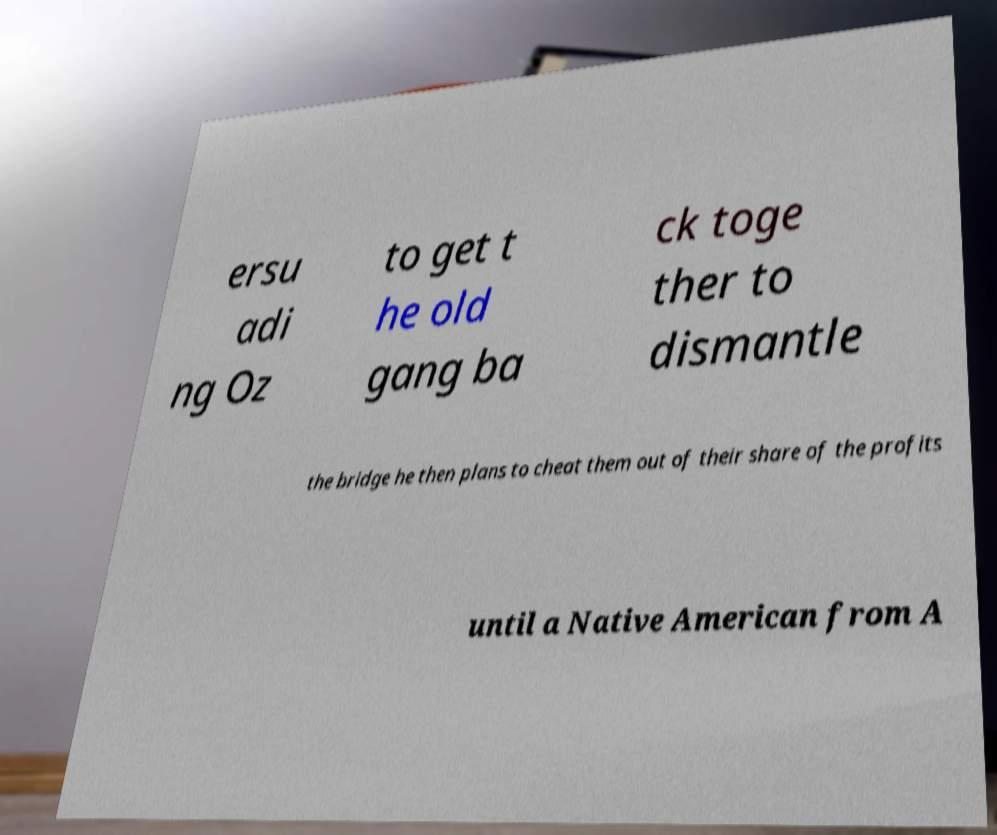I need the written content from this picture converted into text. Can you do that? ersu adi ng Oz to get t he old gang ba ck toge ther to dismantle the bridge he then plans to cheat them out of their share of the profits until a Native American from A 